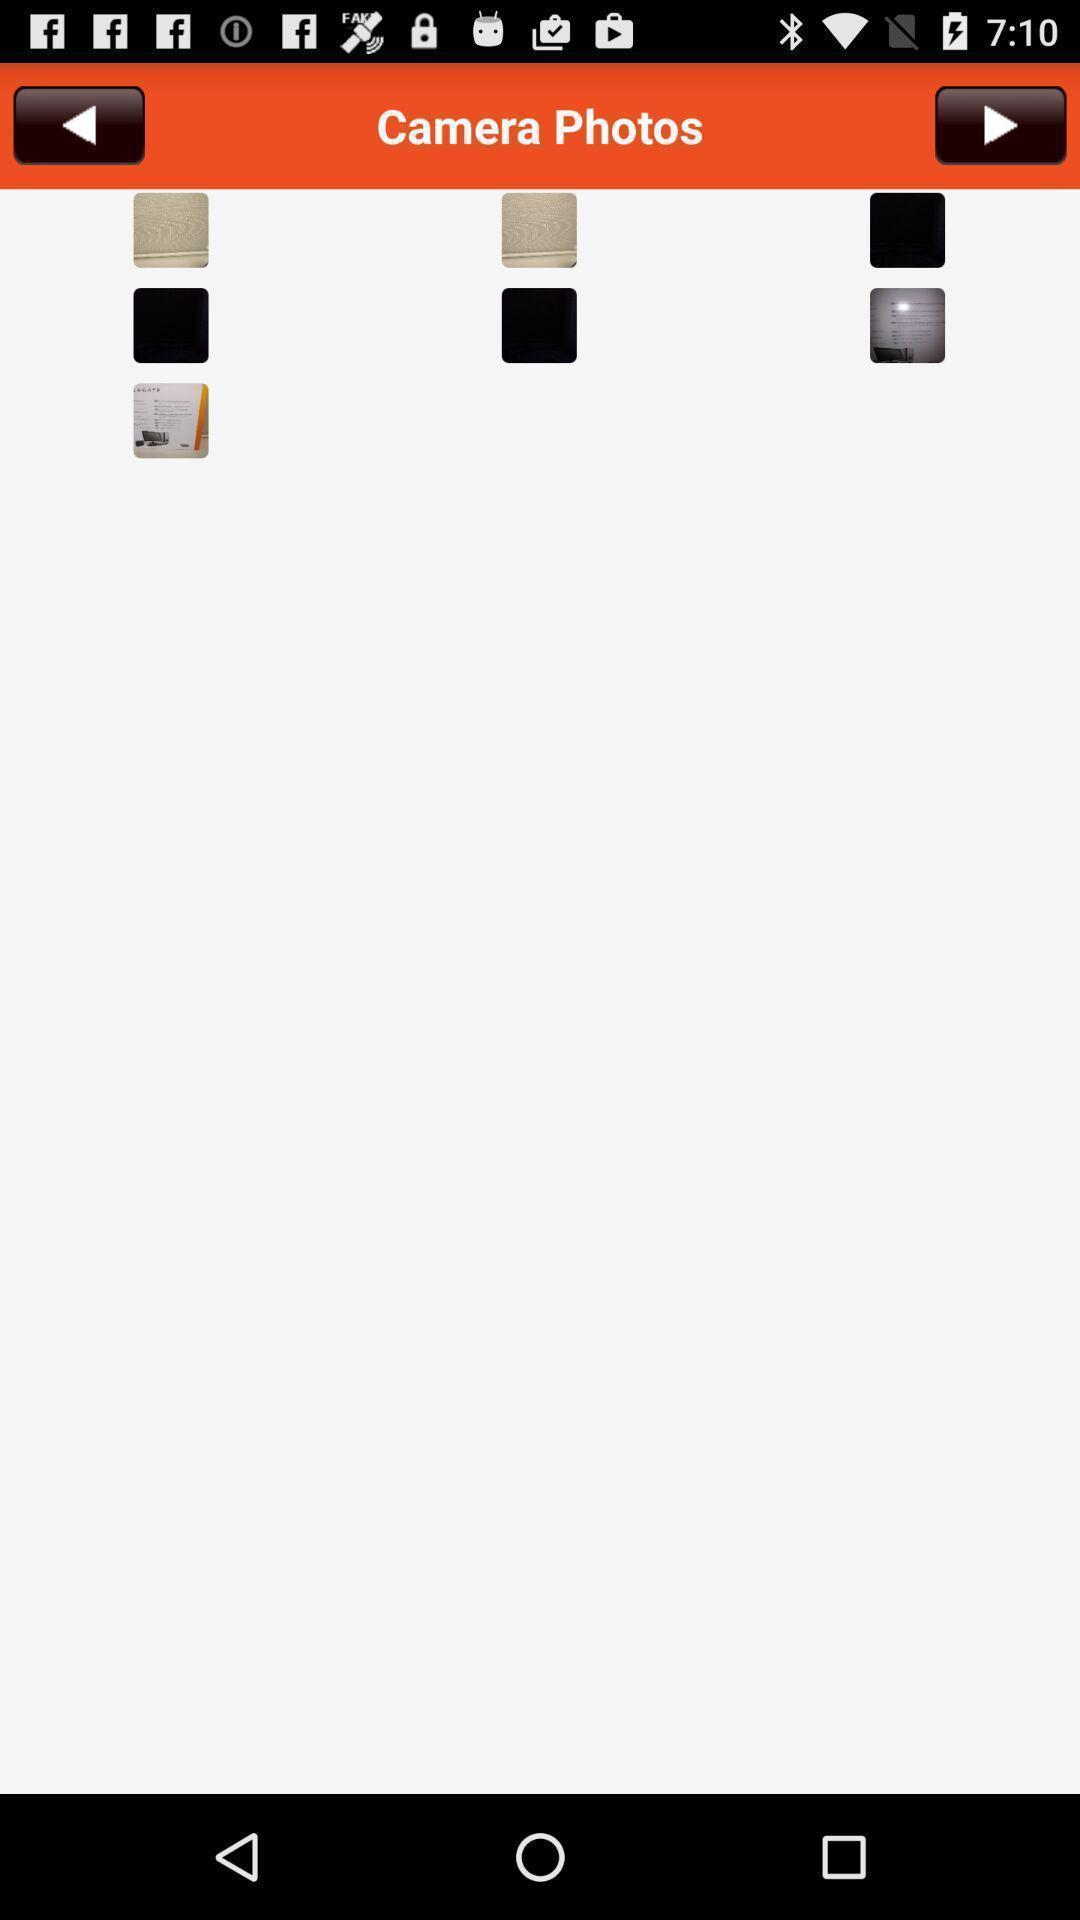What details can you identify in this image? Page showing photos on mobile app. 